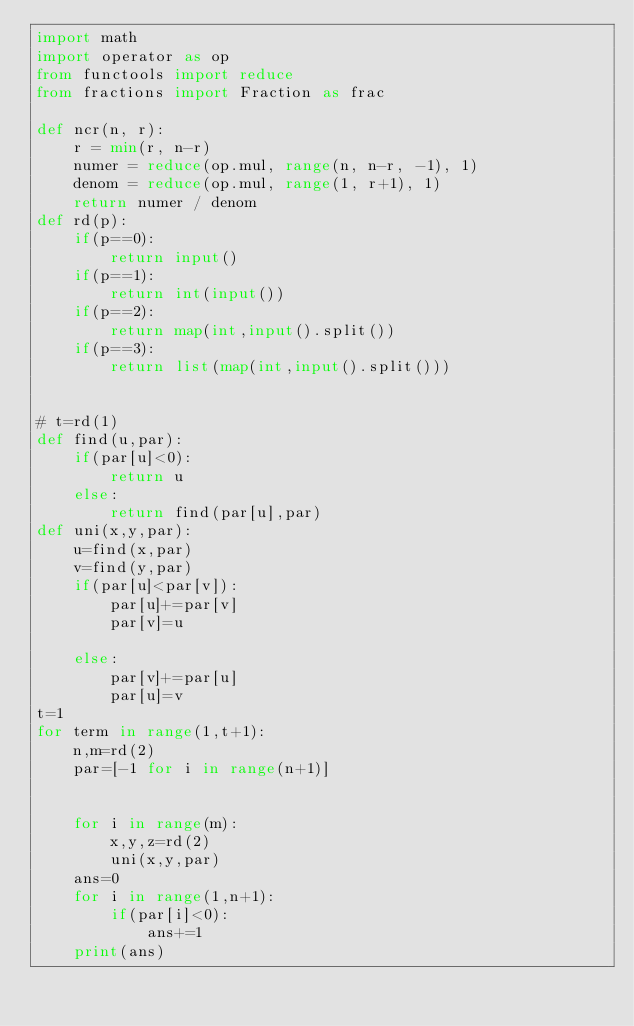<code> <loc_0><loc_0><loc_500><loc_500><_Python_>import math
import operator as op
from functools import reduce
from fractions import Fraction as frac

def ncr(n, r):
    r = min(r, n-r)
    numer = reduce(op.mul, range(n, n-r, -1), 1)
    denom = reduce(op.mul, range(1, r+1), 1)
    return numer / denom
def rd(p):
    if(p==0):
        return input()
    if(p==1):
        return int(input())
    if(p==2):
        return map(int,input().split())
    if(p==3):
        return list(map(int,input().split()))
        

# t=rd(1)
def find(u,par):
    if(par[u]<0):
        return u
    else:
        return find(par[u],par)
def uni(x,y,par):
    u=find(x,par)
    v=find(y,par)
    if(par[u]<par[v]):
        par[u]+=par[v]
        par[v]=u
        
    else:
        par[v]+=par[u]
        par[u]=v
t=1
for term in range(1,t+1):
    n,m=rd(2)
    par=[-1 for i in range(n+1)]
    
    
    for i in range(m):
        x,y,z=rd(2)
        uni(x,y,par)
    ans=0
    for i in range(1,n+1):
        if(par[i]<0):
            ans+=1
    print(ans)
        
    
    </code> 